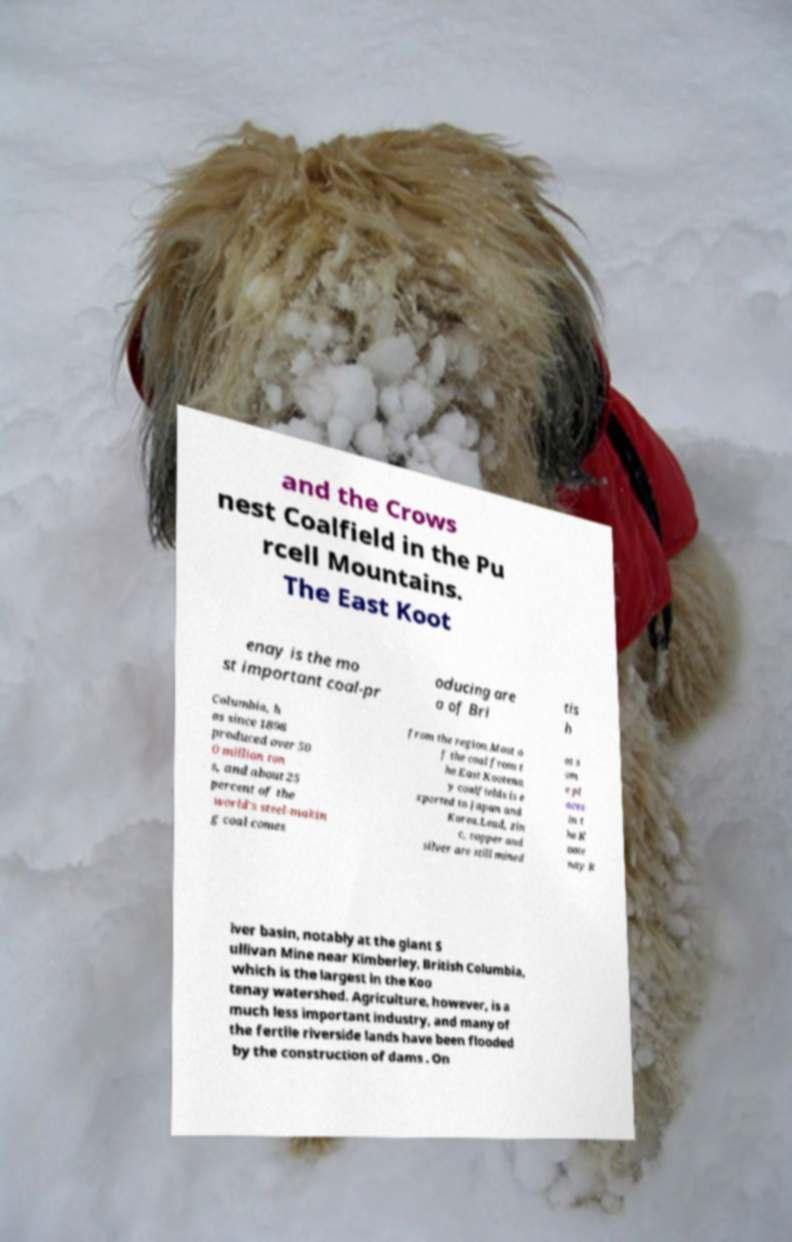Please identify and transcribe the text found in this image. and the Crows nest Coalfield in the Pu rcell Mountains. The East Koot enay is the mo st important coal-pr oducing are a of Bri tis h Columbia, h as since 1898 produced over 50 0 million ton s, and about 25 percent of the world's steel-makin g coal comes from the region.Most o f the coal from t he East Kootena y coalfields is e xported to Japan and Korea.Lead, zin c, copper and silver are still mined at s om e pl aces in t he K oote nay R iver basin, notably at the giant S ullivan Mine near Kimberley, British Columbia, which is the largest in the Koo tenay watershed. Agriculture, however, is a much less important industry, and many of the fertile riverside lands have been flooded by the construction of dams . On 